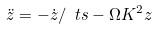<formula> <loc_0><loc_0><loc_500><loc_500>\ddot { z } = - \dot { z } / \ t s - \Omega K ^ { 2 } z</formula> 